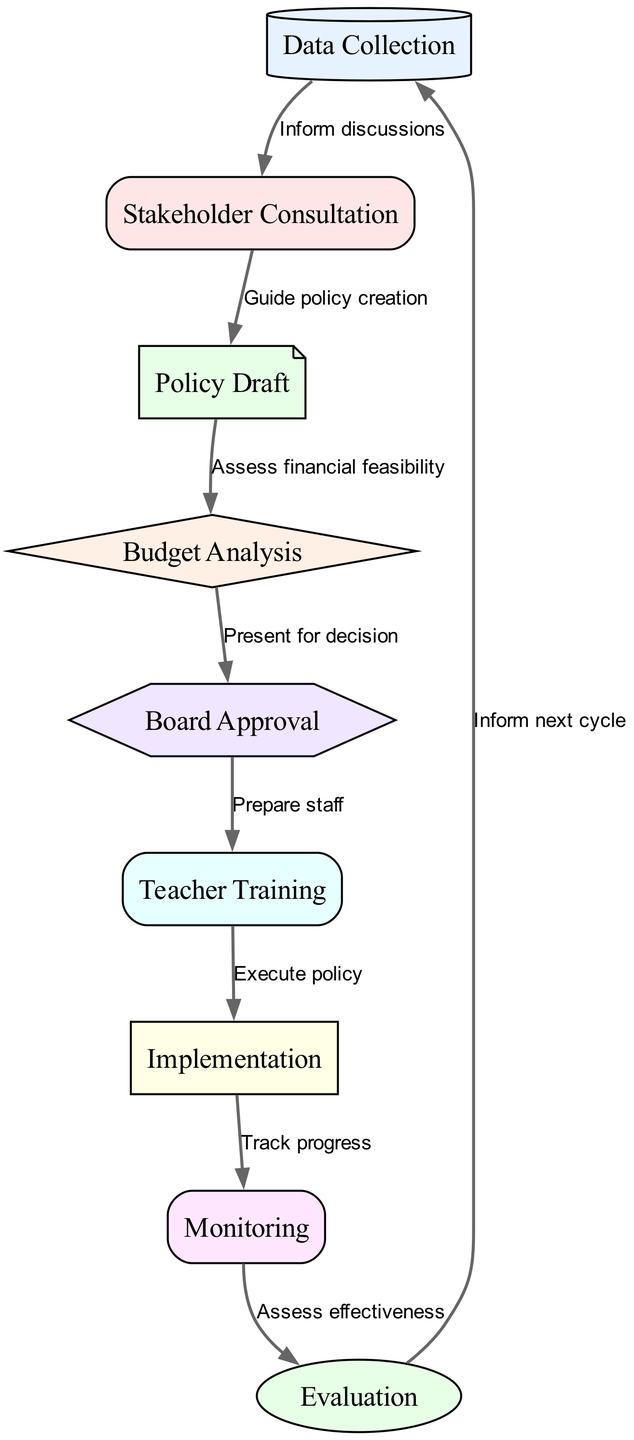What is the first step in the policy implementation process? The first node in the diagram is "Data Collection," which is the initial step in the decision-making process.
Answer: Data Collection How many nodes are present in the diagram? By counting each unique step listed in the nodes section, there are a total of nine nodes representing different stages of the process.
Answer: 9 What is the relationship between "Monitoring" and "Evaluation"? According to the directed edges, "Monitoring" leads to "Evaluation," indicating that monitoring is a prerequisite for evaluation in the process.
Answer: Monitoring leads to Evaluation What action follows "Board Approval"? The diagram shows that after receiving "Board Approval," the next step is "Teacher Training," indicating that preparation for staff occurs following board approval.
Answer: Teacher Training What type of node is "Budget Analysis"? In the diagram, "Budget Analysis" is represented as a diamond shape, a standard convention indicating a decision point in a flow diagram.
Answer: Diamond Which node does "Data Collection" directly inform? The edge labeled "Inform discussions" directs the flow from "Data Collection" to "Stakeholder Consultation," demonstrating a direct relationship in the process.
Answer: Stakeholder Consultation What stage must occur before "Implementation"? The flow from "Teacher Training" to "Implementation" signifies that teacher training must occur prior to the actual implementation of the policy.
Answer: Teacher Training How does "Evaluation" affect "Data Collection"? The edge "Inform next cycle" shows that evaluation feeds back into data collection, indicating that the results of the evaluation are utilized in the next data collection phase.
Answer: Inform next cycle Which node is the last step in the decision-making process? The final node in the flow indicates that after "Evaluation," the process circles back to "Data Collection," marking it as the last step in the current cycle of decision-making.
Answer: Data Collection 